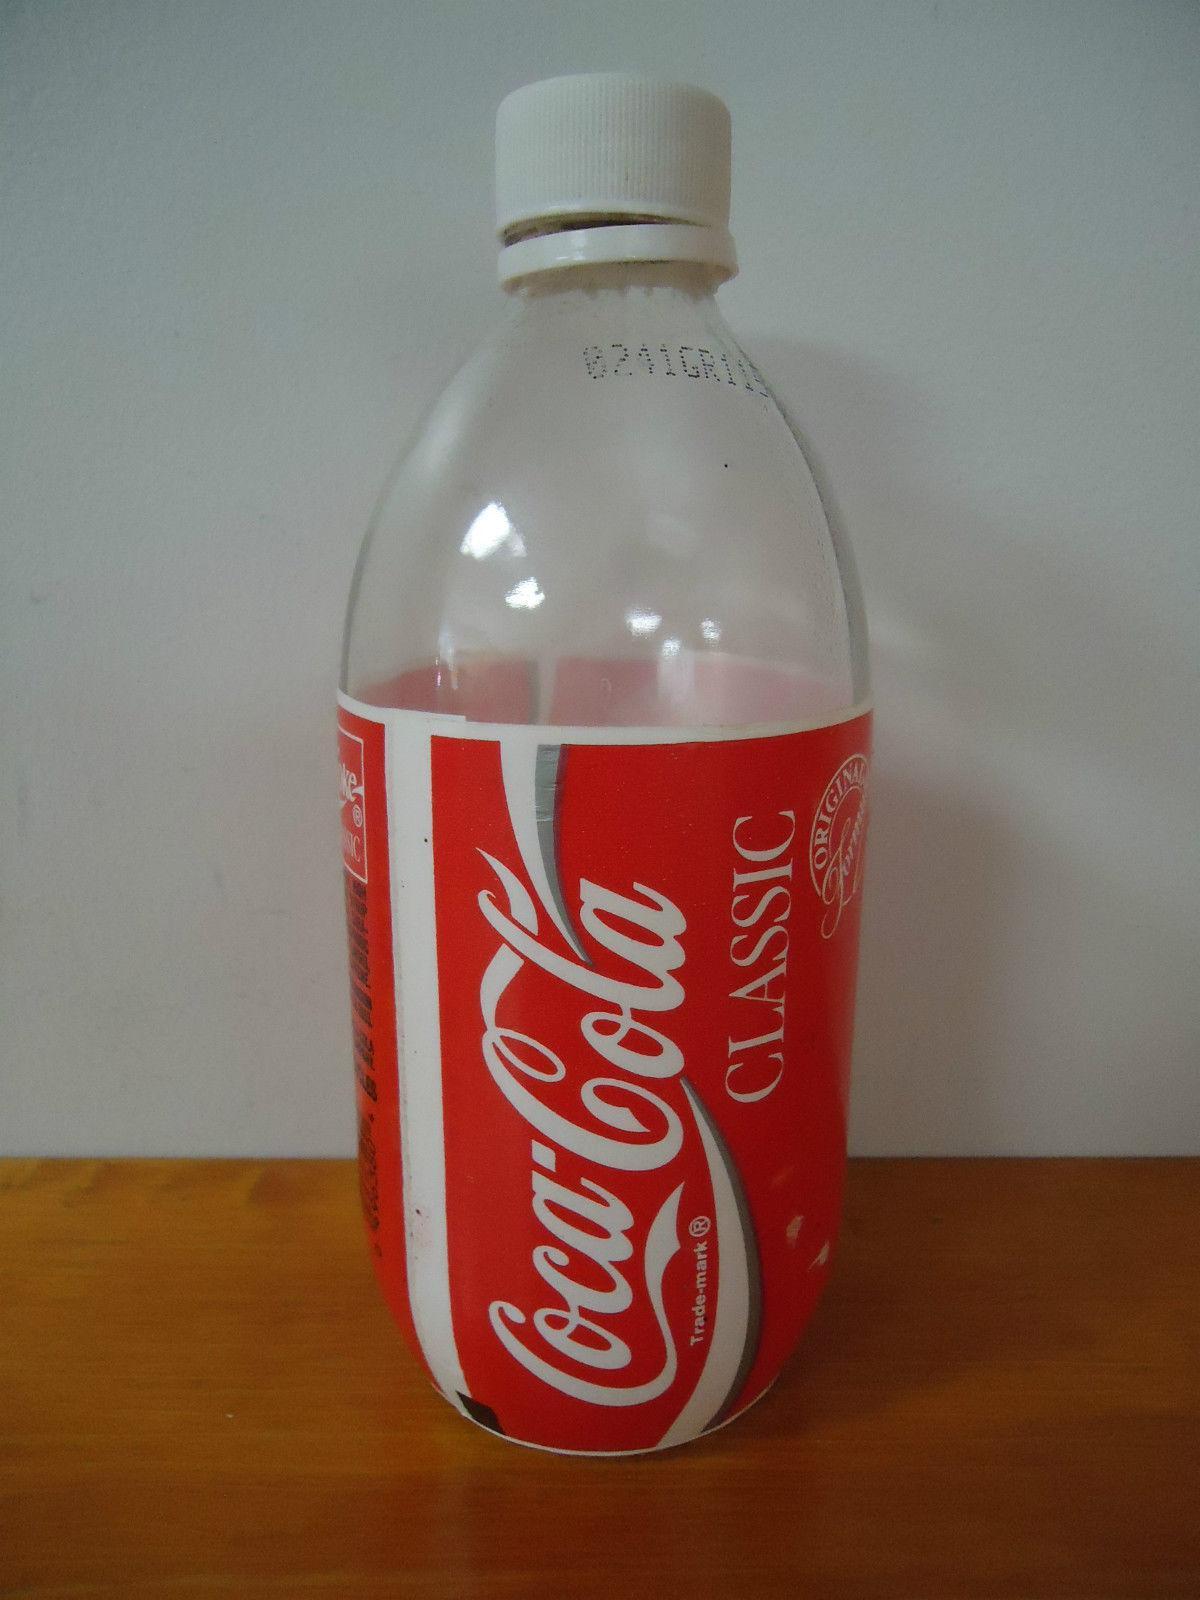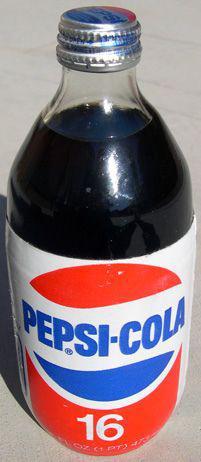The first image is the image on the left, the second image is the image on the right. For the images displayed, is the sentence "All of the bottles have caps." factually correct? Answer yes or no. Yes. The first image is the image on the left, the second image is the image on the right. For the images displayed, is the sentence "The right image contains at least twice as many soda bottles as the left image." factually correct? Answer yes or no. No. 